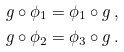Convert formula to latex. <formula><loc_0><loc_0><loc_500><loc_500>g \circ \phi _ { 1 } & = \phi _ { 1 } \circ g \, , \\ g \circ \phi _ { 2 } & = \phi _ { 3 } \circ g \, .</formula> 